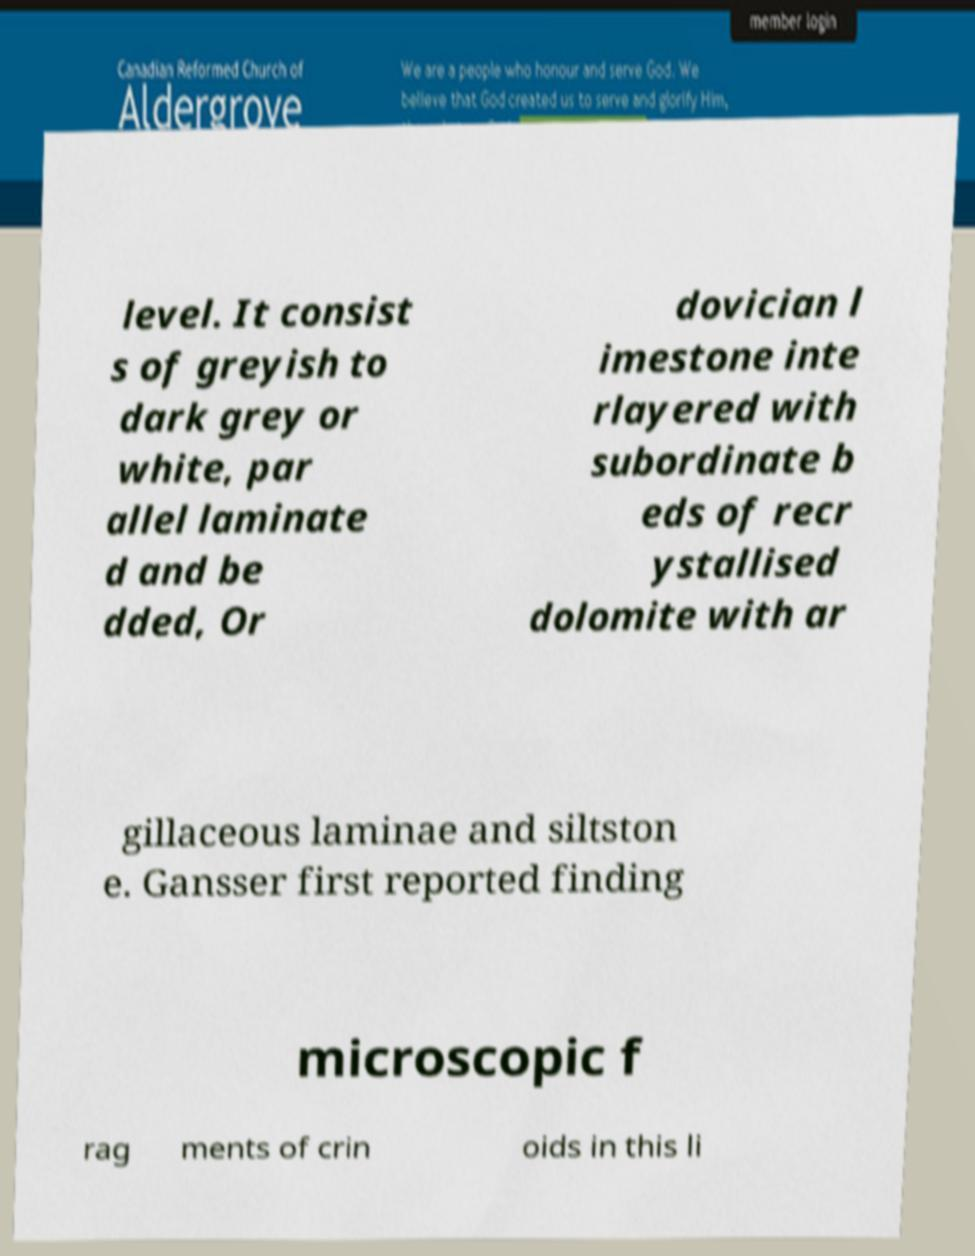What messages or text are displayed in this image? I need them in a readable, typed format. level. It consist s of greyish to dark grey or white, par allel laminate d and be dded, Or dovician l imestone inte rlayered with subordinate b eds of recr ystallised dolomite with ar gillaceous laminae and siltston e. Gansser first reported finding microscopic f rag ments of crin oids in this li 